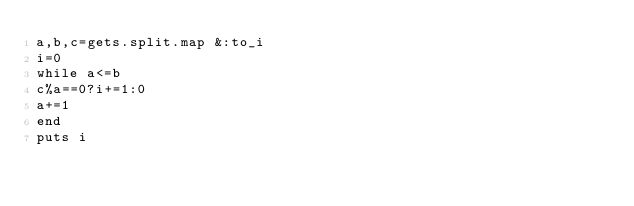Convert code to text. <code><loc_0><loc_0><loc_500><loc_500><_Ruby_>a,b,c=gets.split.map &:to_i
i=0
while a<=b
c%a==0?i+=1:0
a+=1
end
puts i</code> 